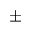Convert formula to latex. <formula><loc_0><loc_0><loc_500><loc_500>\pm</formula> 